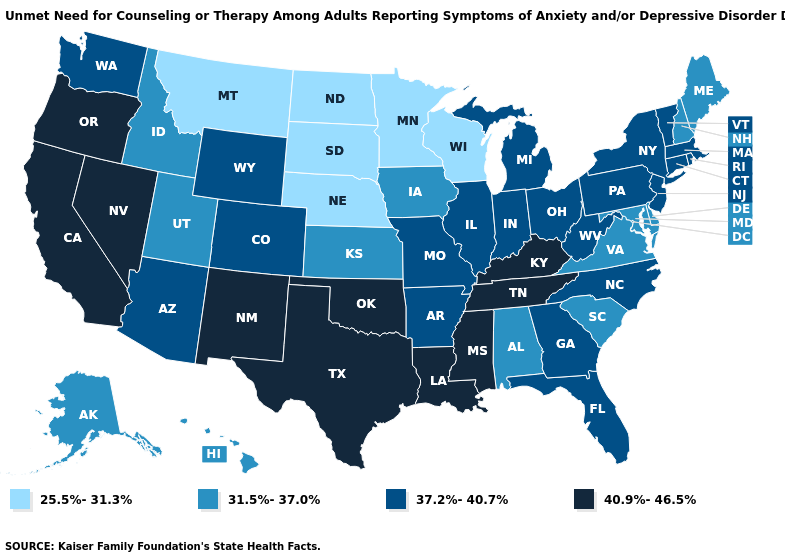Does Vermont have the same value as Arkansas?
Concise answer only. Yes. What is the value of Iowa?
Give a very brief answer. 31.5%-37.0%. Name the states that have a value in the range 31.5%-37.0%?
Short answer required. Alabama, Alaska, Delaware, Hawaii, Idaho, Iowa, Kansas, Maine, Maryland, New Hampshire, South Carolina, Utah, Virginia. Name the states that have a value in the range 40.9%-46.5%?
Quick response, please. California, Kentucky, Louisiana, Mississippi, Nevada, New Mexico, Oklahoma, Oregon, Tennessee, Texas. Does the map have missing data?
Be succinct. No. Does Arizona have the lowest value in the USA?
Answer briefly. No. How many symbols are there in the legend?
Concise answer only. 4. Does Oregon have the highest value in the USA?
Short answer required. Yes. Name the states that have a value in the range 25.5%-31.3%?
Answer briefly. Minnesota, Montana, Nebraska, North Dakota, South Dakota, Wisconsin. Is the legend a continuous bar?
Quick response, please. No. Name the states that have a value in the range 31.5%-37.0%?
Write a very short answer. Alabama, Alaska, Delaware, Hawaii, Idaho, Iowa, Kansas, Maine, Maryland, New Hampshire, South Carolina, Utah, Virginia. Does Michigan have a lower value than Washington?
Give a very brief answer. No. What is the highest value in the USA?
Answer briefly. 40.9%-46.5%. Name the states that have a value in the range 40.9%-46.5%?
Write a very short answer. California, Kentucky, Louisiana, Mississippi, Nevada, New Mexico, Oklahoma, Oregon, Tennessee, Texas. Does the first symbol in the legend represent the smallest category?
Keep it brief. Yes. 